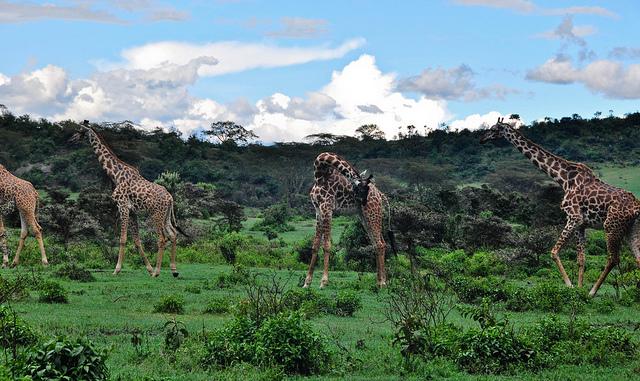How many giraffes?
Keep it brief. 4. Does this giraffe look comfortable reaching down?
Quick response, please. Yes. Are these giraffes all the same size?
Be succinct. Yes. Are they in the wild?
Give a very brief answer. Yes. How many animals are here?
Quick response, please. 4. Is it cloudy?
Write a very short answer. Yes. 